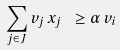<formula> <loc_0><loc_0><loc_500><loc_500>\sum _ { j \in J } v _ { j } \, x _ { j } \ \geq \alpha \, v _ { i }</formula> 